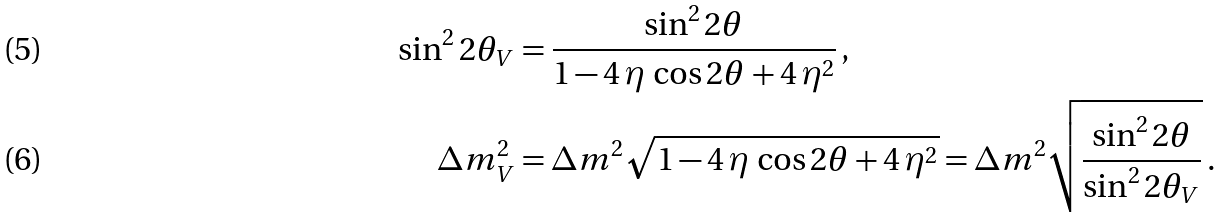Convert formula to latex. <formula><loc_0><loc_0><loc_500><loc_500>\sin ^ { 2 } 2 \theta _ { V } & = \frac { \sin ^ { 2 } 2 \theta } { 1 - 4 \, \eta \, \cos 2 \theta + 4 \, \eta ^ { 2 } } \, , \\ \Delta m _ { V } ^ { 2 } & = \Delta m ^ { 2 } \sqrt { 1 - 4 \, \eta \, \cos 2 \theta + 4 \, \eta ^ { 2 } } = \Delta m ^ { 2 } \sqrt { \frac { \sin ^ { 2 } 2 \theta } { \sin ^ { 2 } 2 \theta _ { V } } } \, .</formula> 